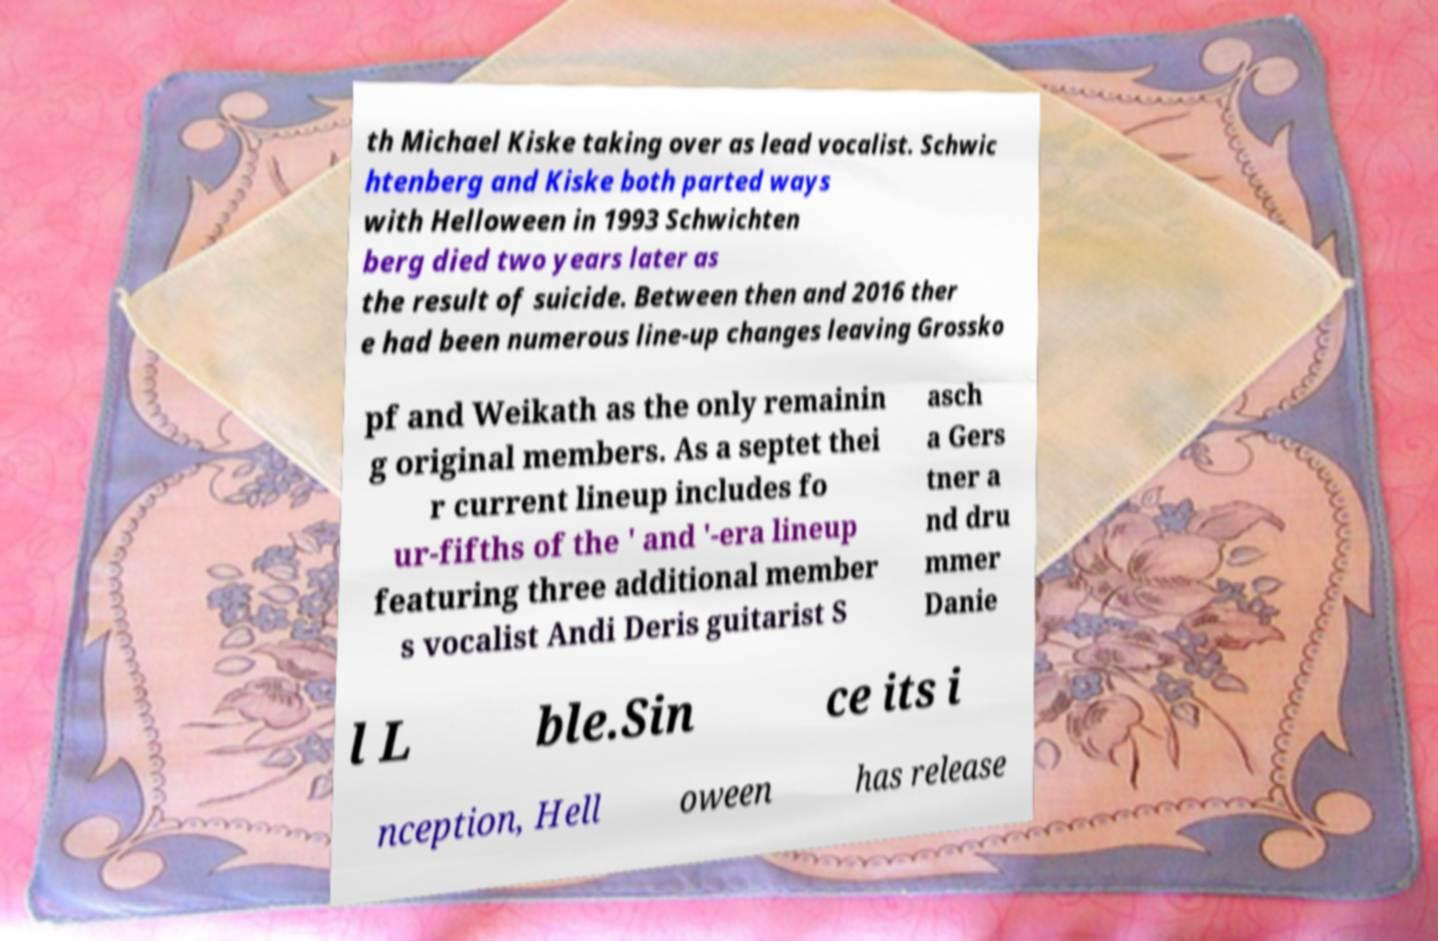I need the written content from this picture converted into text. Can you do that? th Michael Kiske taking over as lead vocalist. Schwic htenberg and Kiske both parted ways with Helloween in 1993 Schwichten berg died two years later as the result of suicide. Between then and 2016 ther e had been numerous line-up changes leaving Grossko pf and Weikath as the only remainin g original members. As a septet thei r current lineup includes fo ur-fifths of the ' and '-era lineup featuring three additional member s vocalist Andi Deris guitarist S asch a Gers tner a nd dru mmer Danie l L ble.Sin ce its i nception, Hell oween has release 